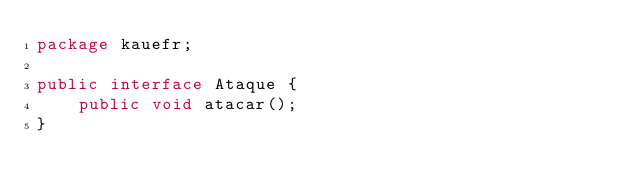<code> <loc_0><loc_0><loc_500><loc_500><_Java_>package kauefr;

public interface Ataque {
    public void atacar();
}
</code> 